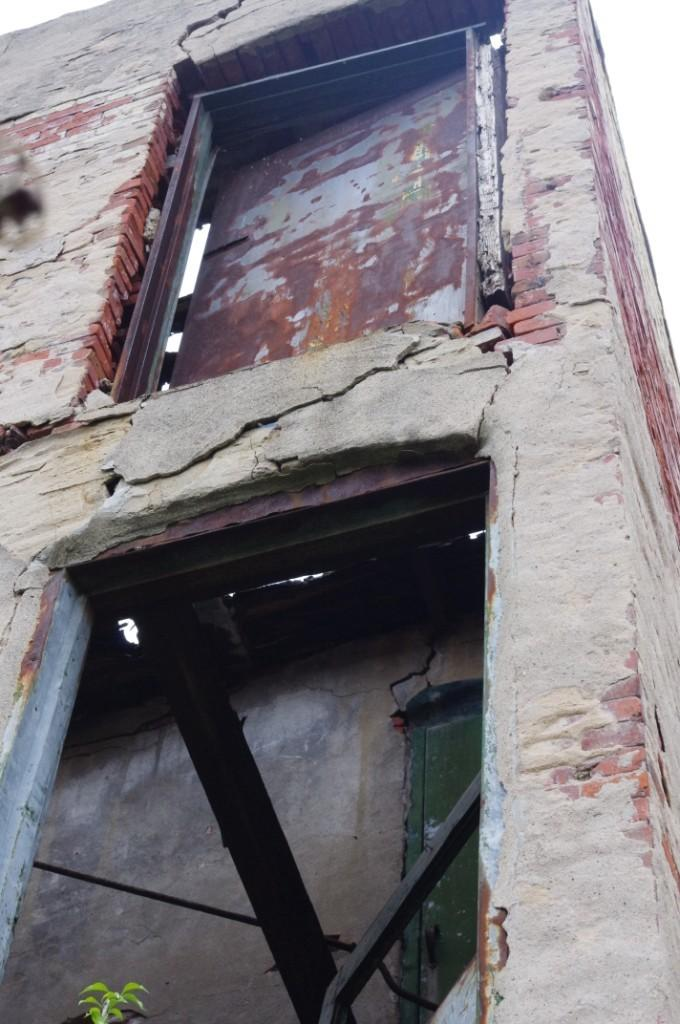What type of structure is depicted in the image? There is an old building wall in the image. How many doors are present in the wall? The wall has two doors. What is the condition of the wall? There are cracks in the wall, and some bricks have come out of the wall. What can be seen in the background of the image? The sky is visible in the background of the image. What grade did the dinosaurs receive for their performance in the image? There are no dinosaurs present in the image, so it is not possible to determine their performance or grade. 